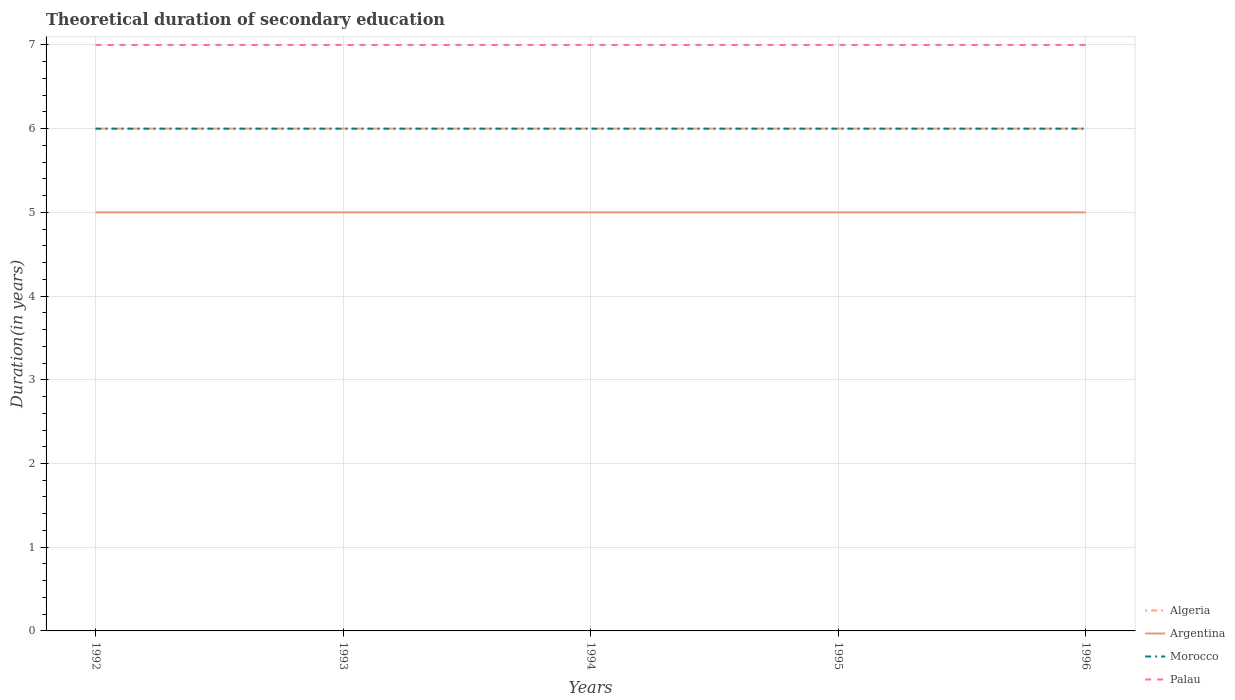Does the line corresponding to Argentina intersect with the line corresponding to Morocco?
Offer a terse response. No. Across all years, what is the maximum total theoretical duration of secondary education in Palau?
Provide a succinct answer. 7. In which year was the total theoretical duration of secondary education in Algeria maximum?
Offer a very short reply. 1992. What is the total total theoretical duration of secondary education in Argentina in the graph?
Offer a terse response. 0. What is the difference between the highest and the lowest total theoretical duration of secondary education in Palau?
Your answer should be compact. 0. Is the total theoretical duration of secondary education in Algeria strictly greater than the total theoretical duration of secondary education in Argentina over the years?
Your response must be concise. No. How many lines are there?
Give a very brief answer. 4. What is the difference between two consecutive major ticks on the Y-axis?
Provide a succinct answer. 1. Are the values on the major ticks of Y-axis written in scientific E-notation?
Your response must be concise. No. Does the graph contain grids?
Your answer should be compact. Yes. Where does the legend appear in the graph?
Offer a terse response. Bottom right. How many legend labels are there?
Keep it short and to the point. 4. How are the legend labels stacked?
Your answer should be very brief. Vertical. What is the title of the graph?
Give a very brief answer. Theoretical duration of secondary education. What is the label or title of the Y-axis?
Your response must be concise. Duration(in years). What is the Duration(in years) of Algeria in 1992?
Make the answer very short. 6. What is the Duration(in years) in Morocco in 1992?
Your answer should be compact. 6. What is the Duration(in years) of Palau in 1992?
Ensure brevity in your answer.  7. What is the Duration(in years) of Morocco in 1993?
Make the answer very short. 6. What is the Duration(in years) of Palau in 1994?
Ensure brevity in your answer.  7. What is the Duration(in years) of Algeria in 1995?
Ensure brevity in your answer.  6. What is the Duration(in years) in Algeria in 1996?
Give a very brief answer. 6. What is the Duration(in years) of Morocco in 1996?
Give a very brief answer. 6. What is the Duration(in years) in Palau in 1996?
Offer a terse response. 7. Across all years, what is the maximum Duration(in years) in Algeria?
Keep it short and to the point. 6. Across all years, what is the maximum Duration(in years) in Argentina?
Provide a short and direct response. 5. Across all years, what is the maximum Duration(in years) of Morocco?
Keep it short and to the point. 6. Across all years, what is the minimum Duration(in years) of Algeria?
Your response must be concise. 6. What is the total Duration(in years) of Morocco in the graph?
Make the answer very short. 30. What is the total Duration(in years) in Palau in the graph?
Provide a succinct answer. 35. What is the difference between the Duration(in years) of Algeria in 1992 and that in 1993?
Ensure brevity in your answer.  0. What is the difference between the Duration(in years) of Argentina in 1992 and that in 1993?
Offer a terse response. 0. What is the difference between the Duration(in years) in Algeria in 1992 and that in 1994?
Ensure brevity in your answer.  0. What is the difference between the Duration(in years) of Morocco in 1992 and that in 1994?
Your answer should be very brief. 0. What is the difference between the Duration(in years) of Algeria in 1992 and that in 1995?
Keep it short and to the point. 0. What is the difference between the Duration(in years) of Morocco in 1992 and that in 1995?
Provide a short and direct response. 0. What is the difference between the Duration(in years) in Morocco in 1992 and that in 1996?
Offer a very short reply. 0. What is the difference between the Duration(in years) of Palau in 1992 and that in 1996?
Offer a very short reply. 0. What is the difference between the Duration(in years) in Morocco in 1993 and that in 1994?
Offer a very short reply. 0. What is the difference between the Duration(in years) in Palau in 1993 and that in 1995?
Provide a short and direct response. 0. What is the difference between the Duration(in years) in Algeria in 1993 and that in 1996?
Offer a very short reply. 0. What is the difference between the Duration(in years) in Argentina in 1993 and that in 1996?
Offer a terse response. 0. What is the difference between the Duration(in years) of Morocco in 1993 and that in 1996?
Your answer should be very brief. 0. What is the difference between the Duration(in years) of Algeria in 1994 and that in 1995?
Keep it short and to the point. 0. What is the difference between the Duration(in years) in Morocco in 1994 and that in 1995?
Keep it short and to the point. 0. What is the difference between the Duration(in years) in Palau in 1994 and that in 1995?
Give a very brief answer. 0. What is the difference between the Duration(in years) in Algeria in 1995 and that in 1996?
Make the answer very short. 0. What is the difference between the Duration(in years) of Algeria in 1992 and the Duration(in years) of Argentina in 1993?
Your response must be concise. 1. What is the difference between the Duration(in years) of Algeria in 1992 and the Duration(in years) of Morocco in 1993?
Provide a short and direct response. 0. What is the difference between the Duration(in years) in Argentina in 1992 and the Duration(in years) in Morocco in 1993?
Ensure brevity in your answer.  -1. What is the difference between the Duration(in years) in Morocco in 1992 and the Duration(in years) in Palau in 1993?
Keep it short and to the point. -1. What is the difference between the Duration(in years) of Algeria in 1992 and the Duration(in years) of Morocco in 1994?
Provide a succinct answer. 0. What is the difference between the Duration(in years) of Algeria in 1992 and the Duration(in years) of Palau in 1994?
Ensure brevity in your answer.  -1. What is the difference between the Duration(in years) of Morocco in 1992 and the Duration(in years) of Palau in 1994?
Provide a succinct answer. -1. What is the difference between the Duration(in years) in Algeria in 1992 and the Duration(in years) in Argentina in 1995?
Offer a terse response. 1. What is the difference between the Duration(in years) in Algeria in 1992 and the Duration(in years) in Morocco in 1995?
Offer a very short reply. 0. What is the difference between the Duration(in years) of Algeria in 1992 and the Duration(in years) of Palau in 1995?
Give a very brief answer. -1. What is the difference between the Duration(in years) in Morocco in 1992 and the Duration(in years) in Palau in 1995?
Offer a very short reply. -1. What is the difference between the Duration(in years) of Algeria in 1992 and the Duration(in years) of Morocco in 1996?
Provide a succinct answer. 0. What is the difference between the Duration(in years) of Argentina in 1992 and the Duration(in years) of Morocco in 1996?
Provide a succinct answer. -1. What is the difference between the Duration(in years) of Argentina in 1992 and the Duration(in years) of Palau in 1996?
Offer a very short reply. -2. What is the difference between the Duration(in years) of Morocco in 1992 and the Duration(in years) of Palau in 1996?
Make the answer very short. -1. What is the difference between the Duration(in years) of Algeria in 1993 and the Duration(in years) of Palau in 1994?
Provide a succinct answer. -1. What is the difference between the Duration(in years) of Argentina in 1993 and the Duration(in years) of Morocco in 1994?
Offer a very short reply. -1. What is the difference between the Duration(in years) in Algeria in 1993 and the Duration(in years) in Palau in 1995?
Keep it short and to the point. -1. What is the difference between the Duration(in years) in Argentina in 1993 and the Duration(in years) in Morocco in 1995?
Your answer should be very brief. -1. What is the difference between the Duration(in years) of Morocco in 1993 and the Duration(in years) of Palau in 1995?
Provide a short and direct response. -1. What is the difference between the Duration(in years) in Algeria in 1993 and the Duration(in years) in Morocco in 1996?
Your response must be concise. 0. What is the difference between the Duration(in years) of Algeria in 1993 and the Duration(in years) of Palau in 1996?
Give a very brief answer. -1. What is the difference between the Duration(in years) in Argentina in 1993 and the Duration(in years) in Morocco in 1996?
Provide a short and direct response. -1. What is the difference between the Duration(in years) in Argentina in 1993 and the Duration(in years) in Palau in 1996?
Keep it short and to the point. -2. What is the difference between the Duration(in years) of Algeria in 1994 and the Duration(in years) of Argentina in 1995?
Make the answer very short. 1. What is the difference between the Duration(in years) of Algeria in 1994 and the Duration(in years) of Morocco in 1995?
Your response must be concise. 0. What is the difference between the Duration(in years) in Morocco in 1994 and the Duration(in years) in Palau in 1995?
Give a very brief answer. -1. What is the difference between the Duration(in years) of Algeria in 1994 and the Duration(in years) of Argentina in 1996?
Provide a succinct answer. 1. What is the difference between the Duration(in years) of Algeria in 1995 and the Duration(in years) of Morocco in 1996?
Give a very brief answer. 0. What is the difference between the Duration(in years) in Algeria in 1995 and the Duration(in years) in Palau in 1996?
Your answer should be compact. -1. What is the difference between the Duration(in years) in Argentina in 1995 and the Duration(in years) in Morocco in 1996?
Your answer should be compact. -1. What is the difference between the Duration(in years) of Argentina in 1995 and the Duration(in years) of Palau in 1996?
Your answer should be very brief. -2. What is the difference between the Duration(in years) in Morocco in 1995 and the Duration(in years) in Palau in 1996?
Ensure brevity in your answer.  -1. What is the average Duration(in years) in Palau per year?
Offer a very short reply. 7. In the year 1992, what is the difference between the Duration(in years) in Algeria and Duration(in years) in Argentina?
Keep it short and to the point. 1. In the year 1992, what is the difference between the Duration(in years) of Argentina and Duration(in years) of Morocco?
Your answer should be compact. -1. In the year 1993, what is the difference between the Duration(in years) of Algeria and Duration(in years) of Morocco?
Give a very brief answer. 0. In the year 1993, what is the difference between the Duration(in years) in Algeria and Duration(in years) in Palau?
Make the answer very short. -1. In the year 1994, what is the difference between the Duration(in years) in Algeria and Duration(in years) in Argentina?
Your answer should be compact. 1. In the year 1994, what is the difference between the Duration(in years) in Algeria and Duration(in years) in Morocco?
Give a very brief answer. 0. In the year 1994, what is the difference between the Duration(in years) of Algeria and Duration(in years) of Palau?
Provide a short and direct response. -1. In the year 1994, what is the difference between the Duration(in years) of Morocco and Duration(in years) of Palau?
Your response must be concise. -1. In the year 1995, what is the difference between the Duration(in years) in Algeria and Duration(in years) in Argentina?
Ensure brevity in your answer.  1. In the year 1995, what is the difference between the Duration(in years) in Argentina and Duration(in years) in Palau?
Ensure brevity in your answer.  -2. In the year 1996, what is the difference between the Duration(in years) in Algeria and Duration(in years) in Argentina?
Give a very brief answer. 1. In the year 1996, what is the difference between the Duration(in years) of Argentina and Duration(in years) of Morocco?
Offer a terse response. -1. In the year 1996, what is the difference between the Duration(in years) in Morocco and Duration(in years) in Palau?
Make the answer very short. -1. What is the ratio of the Duration(in years) of Algeria in 1992 to that in 1993?
Your answer should be very brief. 1. What is the ratio of the Duration(in years) of Argentina in 1992 to that in 1993?
Provide a short and direct response. 1. What is the ratio of the Duration(in years) of Morocco in 1992 to that in 1993?
Offer a very short reply. 1. What is the ratio of the Duration(in years) of Palau in 1992 to that in 1993?
Make the answer very short. 1. What is the ratio of the Duration(in years) of Argentina in 1992 to that in 1994?
Your answer should be compact. 1. What is the ratio of the Duration(in years) of Palau in 1992 to that in 1994?
Your answer should be very brief. 1. What is the ratio of the Duration(in years) in Morocco in 1992 to that in 1995?
Keep it short and to the point. 1. What is the ratio of the Duration(in years) of Argentina in 1992 to that in 1996?
Offer a terse response. 1. What is the ratio of the Duration(in years) of Argentina in 1993 to that in 1994?
Keep it short and to the point. 1. What is the ratio of the Duration(in years) in Morocco in 1993 to that in 1994?
Provide a short and direct response. 1. What is the ratio of the Duration(in years) in Argentina in 1993 to that in 1995?
Provide a succinct answer. 1. What is the ratio of the Duration(in years) in Morocco in 1993 to that in 1995?
Your response must be concise. 1. What is the ratio of the Duration(in years) of Algeria in 1993 to that in 1996?
Offer a very short reply. 1. What is the ratio of the Duration(in years) of Argentina in 1993 to that in 1996?
Give a very brief answer. 1. What is the ratio of the Duration(in years) of Morocco in 1993 to that in 1996?
Offer a very short reply. 1. What is the ratio of the Duration(in years) in Palau in 1994 to that in 1995?
Provide a short and direct response. 1. What is the ratio of the Duration(in years) in Algeria in 1994 to that in 1996?
Offer a terse response. 1. What is the ratio of the Duration(in years) in Argentina in 1994 to that in 1996?
Your answer should be very brief. 1. What is the ratio of the Duration(in years) in Morocco in 1995 to that in 1996?
Offer a very short reply. 1. What is the ratio of the Duration(in years) in Palau in 1995 to that in 1996?
Keep it short and to the point. 1. What is the difference between the highest and the second highest Duration(in years) of Morocco?
Your response must be concise. 0. What is the difference between the highest and the second highest Duration(in years) in Palau?
Your response must be concise. 0. What is the difference between the highest and the lowest Duration(in years) of Palau?
Your response must be concise. 0. 